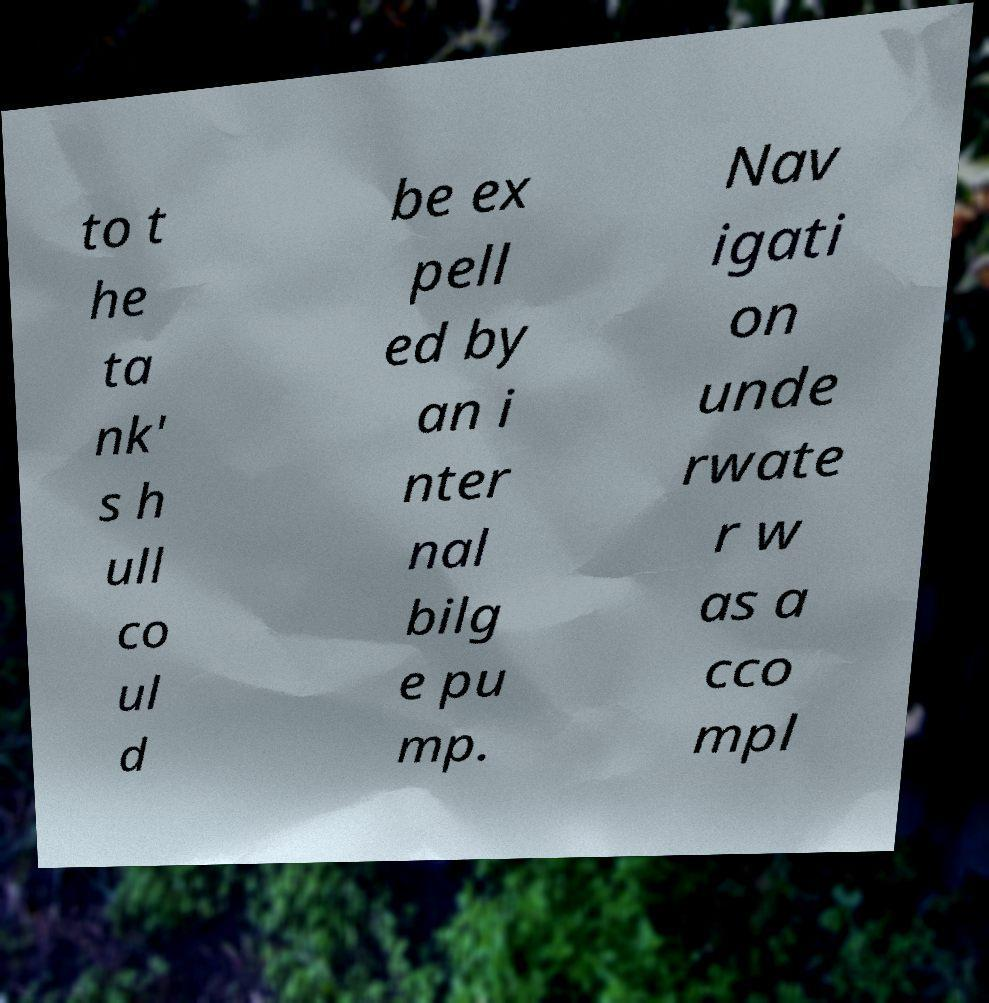Could you extract and type out the text from this image? to t he ta nk' s h ull co ul d be ex pell ed by an i nter nal bilg e pu mp. Nav igati on unde rwate r w as a cco mpl 